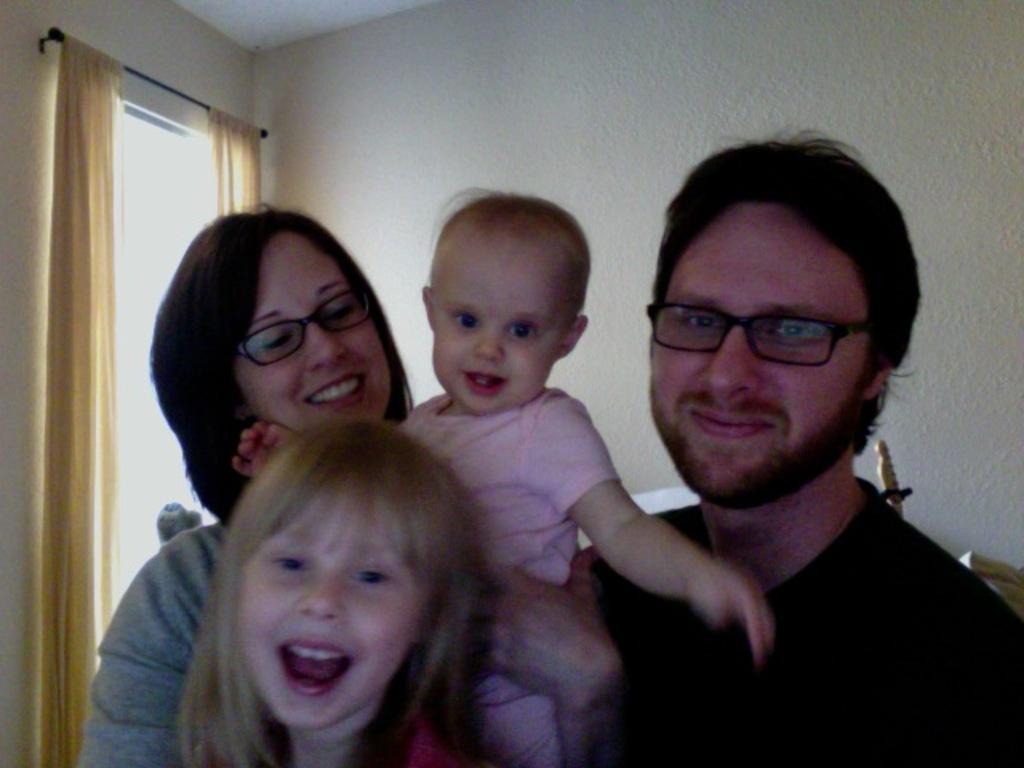In one or two sentences, can you explain what this image depicts? In this image we can see few people in a room, a person is holding a baby and in the background there is a wall and a window with curtains to the rod on the left side. 